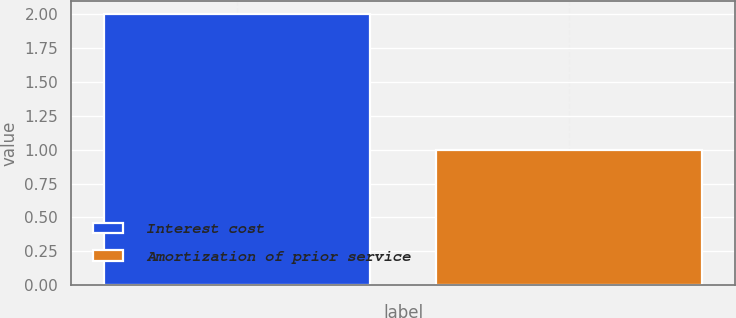<chart> <loc_0><loc_0><loc_500><loc_500><bar_chart><fcel>Interest cost<fcel>Amortization of prior service<nl><fcel>2<fcel>1<nl></chart> 